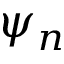Convert formula to latex. <formula><loc_0><loc_0><loc_500><loc_500>\psi _ { n }</formula> 